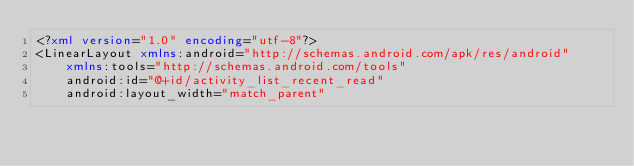Convert code to text. <code><loc_0><loc_0><loc_500><loc_500><_XML_><?xml version="1.0" encoding="utf-8"?>
<LinearLayout xmlns:android="http://schemas.android.com/apk/res/android"
    xmlns:tools="http://schemas.android.com/tools"
    android:id="@+id/activity_list_recent_read"
    android:layout_width="match_parent"</code> 